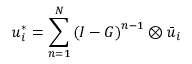Convert formula to latex. <formula><loc_0><loc_0><loc_500><loc_500>{ u _ { i } ^ { * } } = \sum _ { n = 1 } ^ { N } { { { ( I - G ) } ^ { n - 1 } } } \otimes { { { \bar { u } } _ { i } } }</formula> 